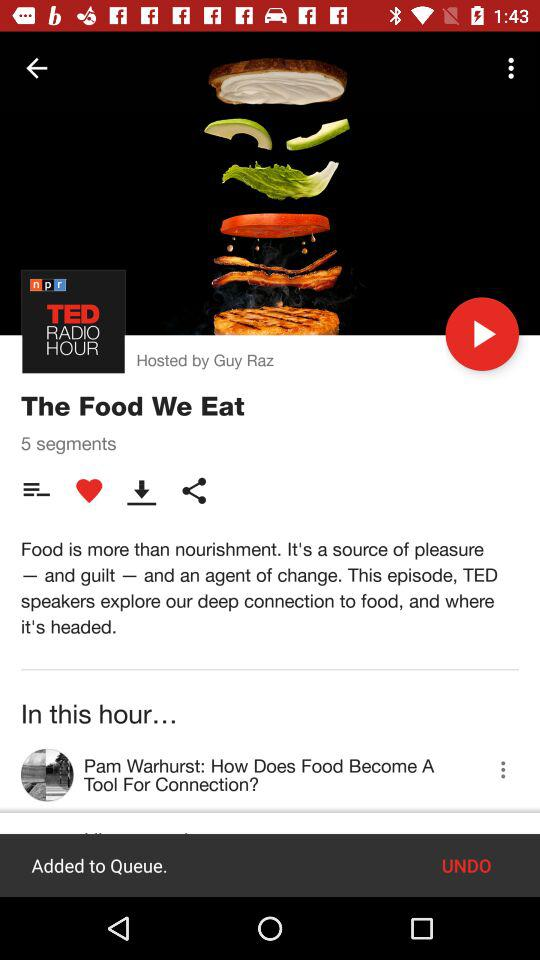How many likes are there?
When the provided information is insufficient, respond with <no answer>. <no answer> 